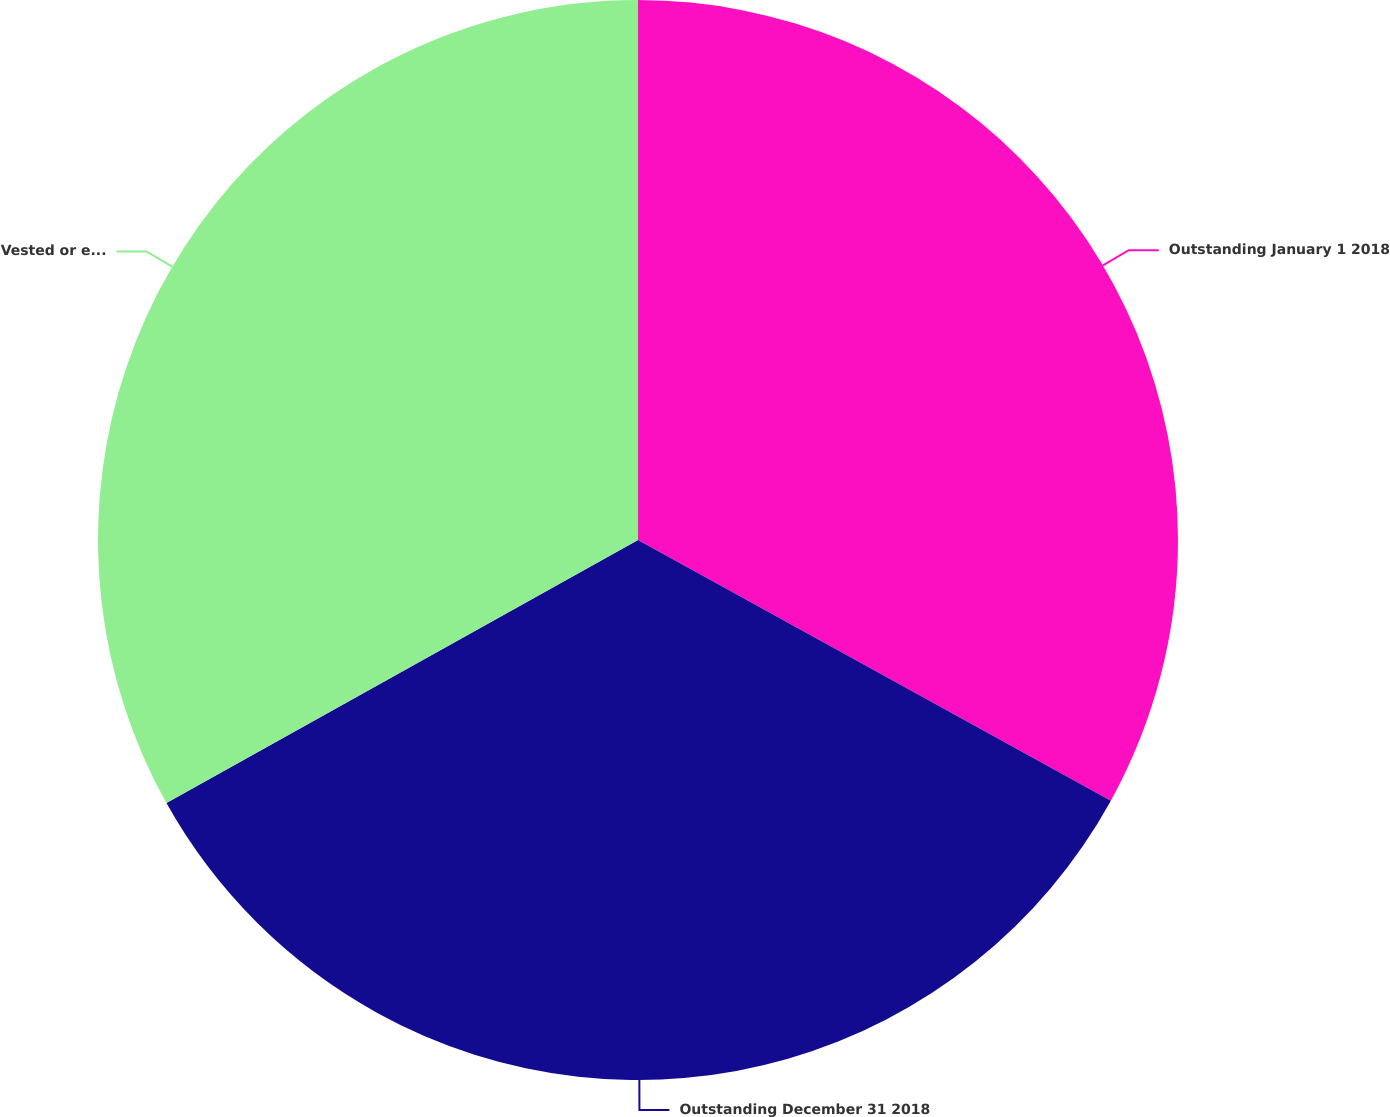Convert chart to OTSL. <chart><loc_0><loc_0><loc_500><loc_500><pie_chart><fcel>Outstanding January 1 2018<fcel>Outstanding December 31 2018<fcel>Vested or expected to vest<nl><fcel>33.02%<fcel>33.88%<fcel>33.1%<nl></chart> 